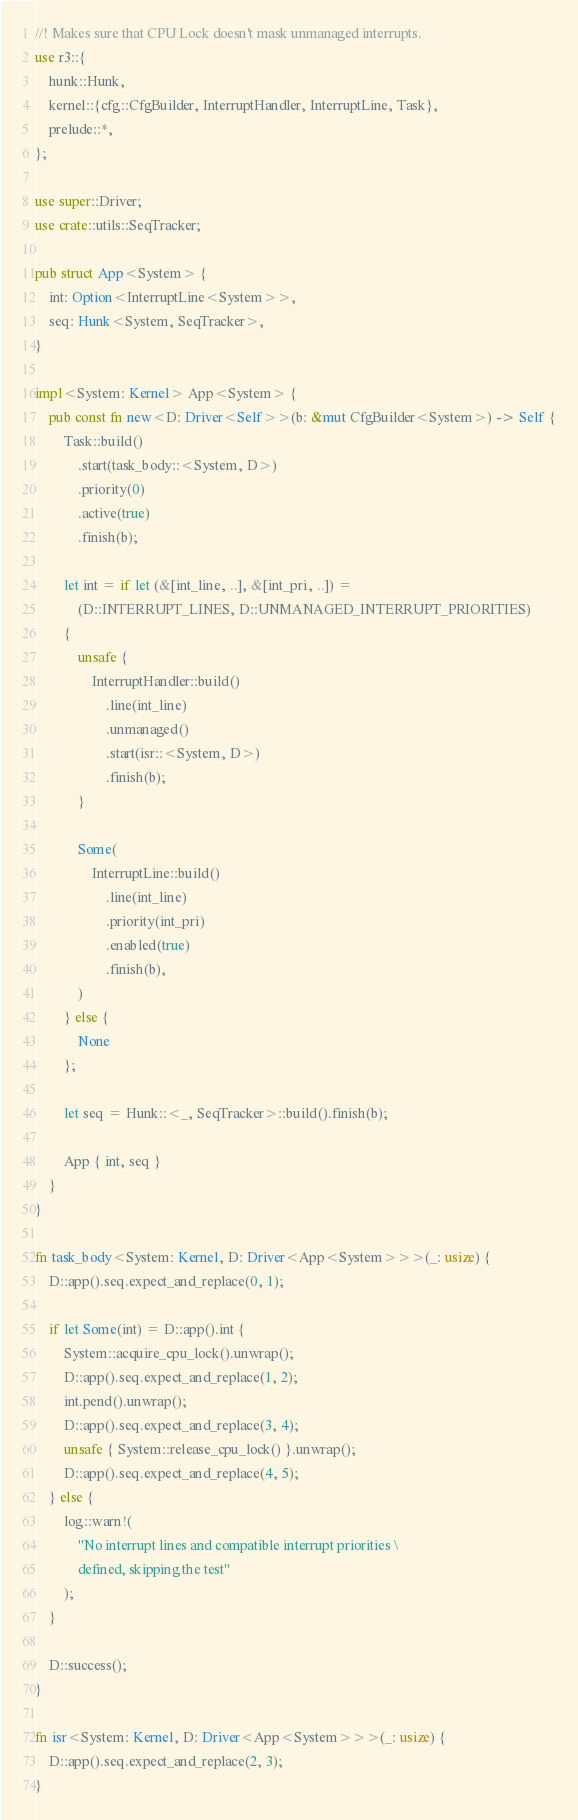<code> <loc_0><loc_0><loc_500><loc_500><_Rust_>//! Makes sure that CPU Lock doesn't mask unmanaged interrupts.
use r3::{
    hunk::Hunk,
    kernel::{cfg::CfgBuilder, InterruptHandler, InterruptLine, Task},
    prelude::*,
};

use super::Driver;
use crate::utils::SeqTracker;

pub struct App<System> {
    int: Option<InterruptLine<System>>,
    seq: Hunk<System, SeqTracker>,
}

impl<System: Kernel> App<System> {
    pub const fn new<D: Driver<Self>>(b: &mut CfgBuilder<System>) -> Self {
        Task::build()
            .start(task_body::<System, D>)
            .priority(0)
            .active(true)
            .finish(b);

        let int = if let (&[int_line, ..], &[int_pri, ..]) =
            (D::INTERRUPT_LINES, D::UNMANAGED_INTERRUPT_PRIORITIES)
        {
            unsafe {
                InterruptHandler::build()
                    .line(int_line)
                    .unmanaged()
                    .start(isr::<System, D>)
                    .finish(b);
            }

            Some(
                InterruptLine::build()
                    .line(int_line)
                    .priority(int_pri)
                    .enabled(true)
                    .finish(b),
            )
        } else {
            None
        };

        let seq = Hunk::<_, SeqTracker>::build().finish(b);

        App { int, seq }
    }
}

fn task_body<System: Kernel, D: Driver<App<System>>>(_: usize) {
    D::app().seq.expect_and_replace(0, 1);

    if let Some(int) = D::app().int {
        System::acquire_cpu_lock().unwrap();
        D::app().seq.expect_and_replace(1, 2);
        int.pend().unwrap();
        D::app().seq.expect_and_replace(3, 4);
        unsafe { System::release_cpu_lock() }.unwrap();
        D::app().seq.expect_and_replace(4, 5);
    } else {
        log::warn!(
            "No interrupt lines and compatible interrupt priorities \
            defined, skipping the test"
        );
    }

    D::success();
}

fn isr<System: Kernel, D: Driver<App<System>>>(_: usize) {
    D::app().seq.expect_and_replace(2, 3);
}
</code> 